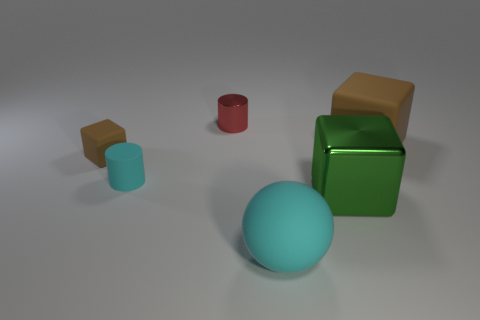Is the color of the big rubber cube the same as the tiny block?
Your answer should be very brief. Yes. What color is the tiny rubber object that is the same shape as the large green thing?
Your response must be concise. Brown. Do the rubber thing that is behind the tiny brown rubber thing and the small block have the same color?
Provide a short and direct response. Yes. What shape is the big matte object that is the same color as the small rubber cylinder?
Offer a terse response. Sphere. What number of other blocks have the same material as the small brown cube?
Your answer should be very brief. 1. How many brown rubber cubes are behind the rubber cylinder?
Give a very brief answer. 2. The red thing is what size?
Offer a very short reply. Small. There is a matte block that is the same size as the shiny cylinder; what color is it?
Keep it short and to the point. Brown. Is there a matte object that has the same color as the small rubber block?
Your answer should be compact. Yes. What is the large green block made of?
Provide a short and direct response. Metal. 